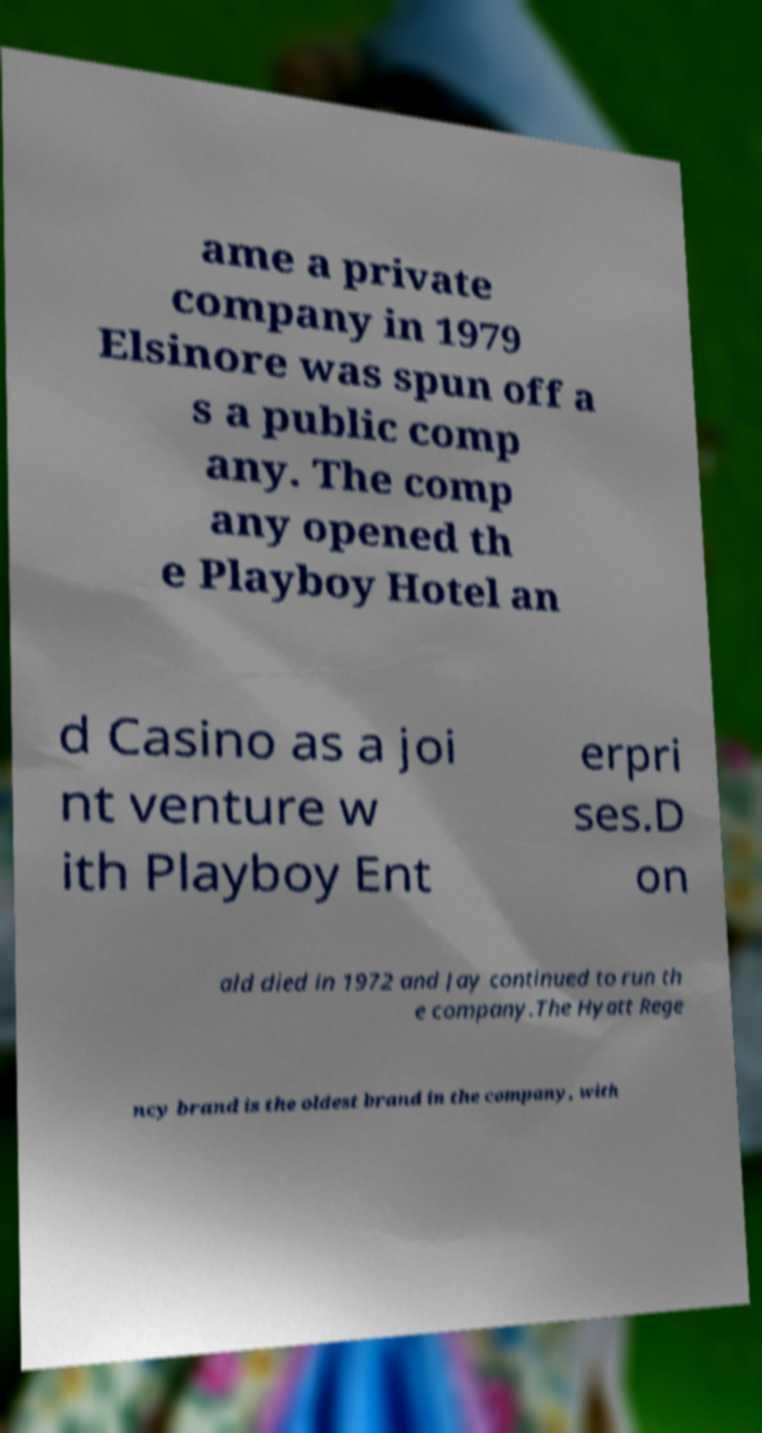Please identify and transcribe the text found in this image. ame a private company in 1979 Elsinore was spun off a s a public comp any. The comp any opened th e Playboy Hotel an d Casino as a joi nt venture w ith Playboy Ent erpri ses.D on ald died in 1972 and Jay continued to run th e company.The Hyatt Rege ncy brand is the oldest brand in the company, with 